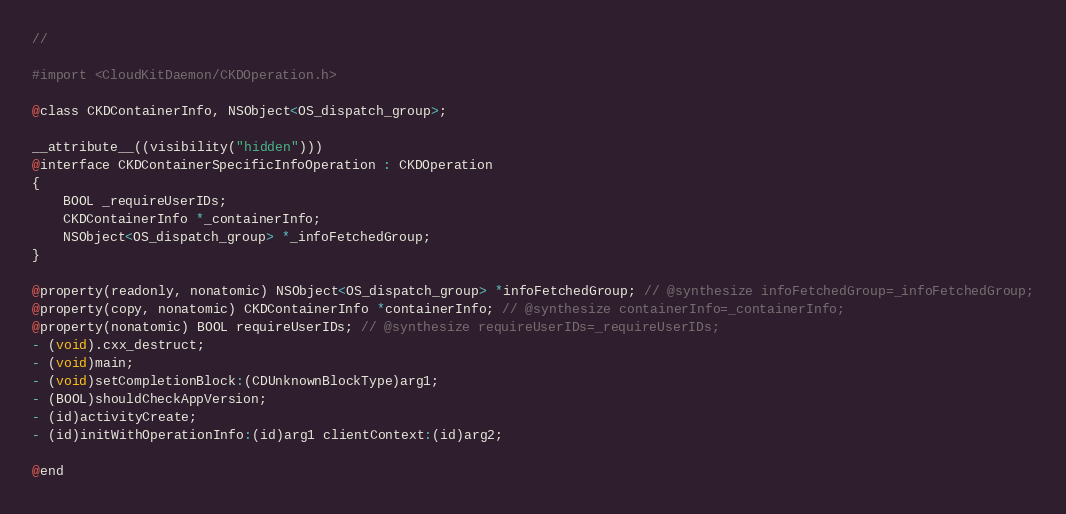Convert code to text. <code><loc_0><loc_0><loc_500><loc_500><_C_>//

#import <CloudKitDaemon/CKDOperation.h>

@class CKDContainerInfo, NSObject<OS_dispatch_group>;

__attribute__((visibility("hidden")))
@interface CKDContainerSpecificInfoOperation : CKDOperation
{
    BOOL _requireUserIDs;
    CKDContainerInfo *_containerInfo;
    NSObject<OS_dispatch_group> *_infoFetchedGroup;
}

@property(readonly, nonatomic) NSObject<OS_dispatch_group> *infoFetchedGroup; // @synthesize infoFetchedGroup=_infoFetchedGroup;
@property(copy, nonatomic) CKDContainerInfo *containerInfo; // @synthesize containerInfo=_containerInfo;
@property(nonatomic) BOOL requireUserIDs; // @synthesize requireUserIDs=_requireUserIDs;
- (void).cxx_destruct;
- (void)main;
- (void)setCompletionBlock:(CDUnknownBlockType)arg1;
- (BOOL)shouldCheckAppVersion;
- (id)activityCreate;
- (id)initWithOperationInfo:(id)arg1 clientContext:(id)arg2;

@end

</code> 